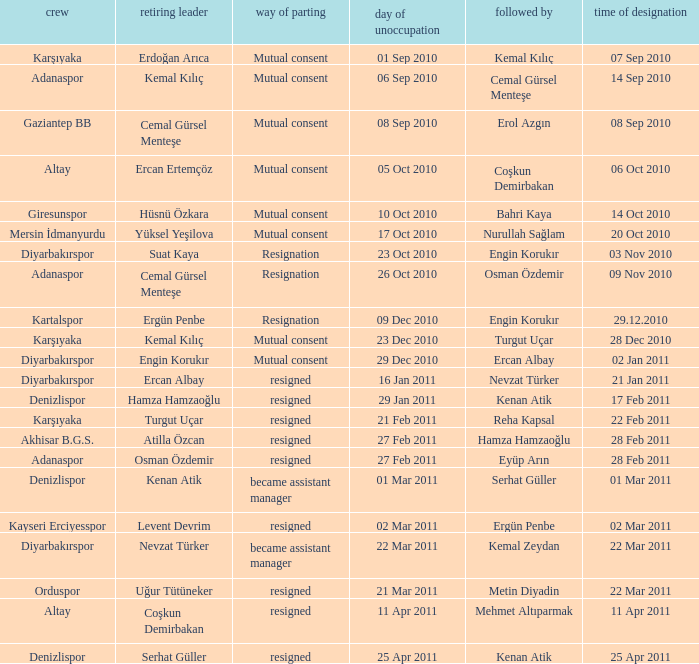When was the date of vacancy for the manager of Kartalspor?  09 Dec 2010. 